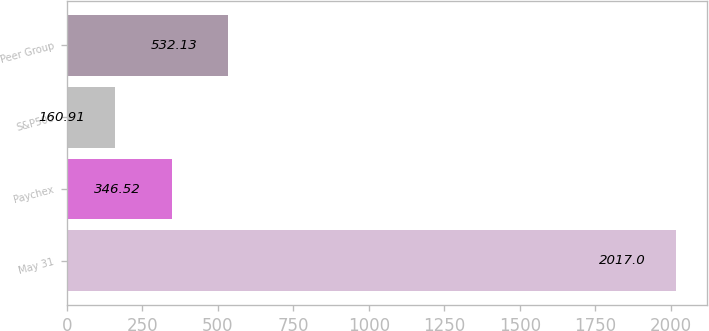Convert chart to OTSL. <chart><loc_0><loc_0><loc_500><loc_500><bar_chart><fcel>May 31<fcel>Paychex<fcel>S&P500<fcel>Peer Group<nl><fcel>2017<fcel>346.52<fcel>160.91<fcel>532.13<nl></chart> 